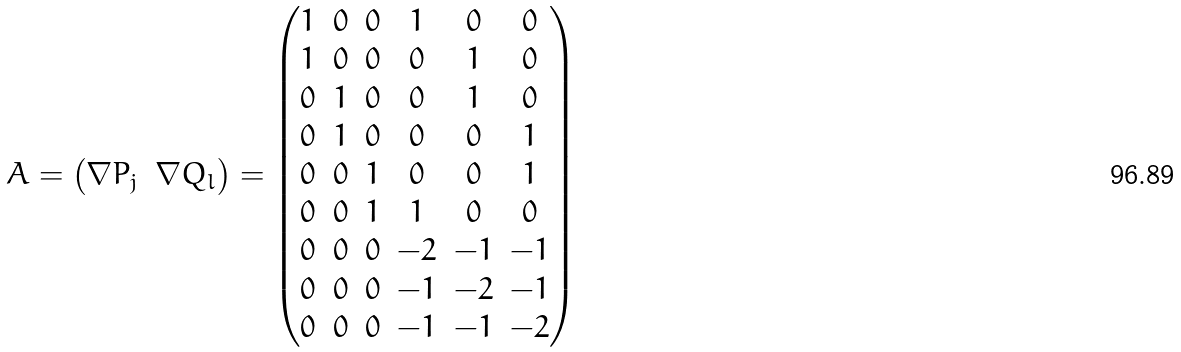Convert formula to latex. <formula><loc_0><loc_0><loc_500><loc_500>A = \begin{pmatrix} \nabla P _ { j } & \nabla Q _ { l } \end{pmatrix} = \begin{pmatrix} 1 & 0 & 0 & 1 & 0 & 0 \\ 1 & 0 & 0 & 0 & 1 & 0 \\ 0 & 1 & 0 & 0 & 1 & 0 \\ 0 & 1 & 0 & 0 & 0 & 1 \\ 0 & 0 & 1 & 0 & 0 & 1 \\ 0 & 0 & 1 & 1 & 0 & 0 \\ 0 & 0 & 0 & - 2 & - 1 & - 1 \\ 0 & 0 & 0 & - 1 & - 2 & - 1 \\ 0 & 0 & 0 & - 1 & - 1 & - 2 \end{pmatrix}</formula> 